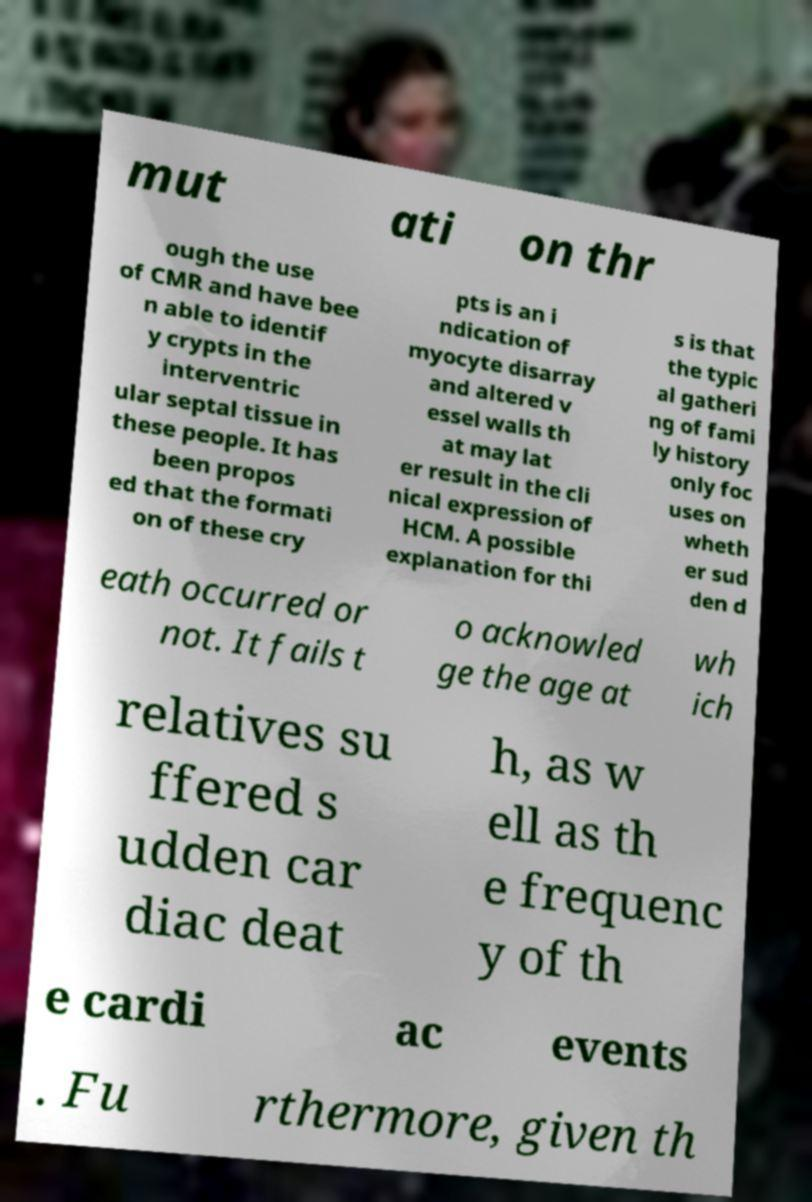Could you assist in decoding the text presented in this image and type it out clearly? mut ati on thr ough the use of CMR and have bee n able to identif y crypts in the interventric ular septal tissue in these people. It has been propos ed that the formati on of these cry pts is an i ndication of myocyte disarray and altered v essel walls th at may lat er result in the cli nical expression of HCM. A possible explanation for thi s is that the typic al gatheri ng of fami ly history only foc uses on wheth er sud den d eath occurred or not. It fails t o acknowled ge the age at wh ich relatives su ffered s udden car diac deat h, as w ell as th e frequenc y of th e cardi ac events . Fu rthermore, given th 